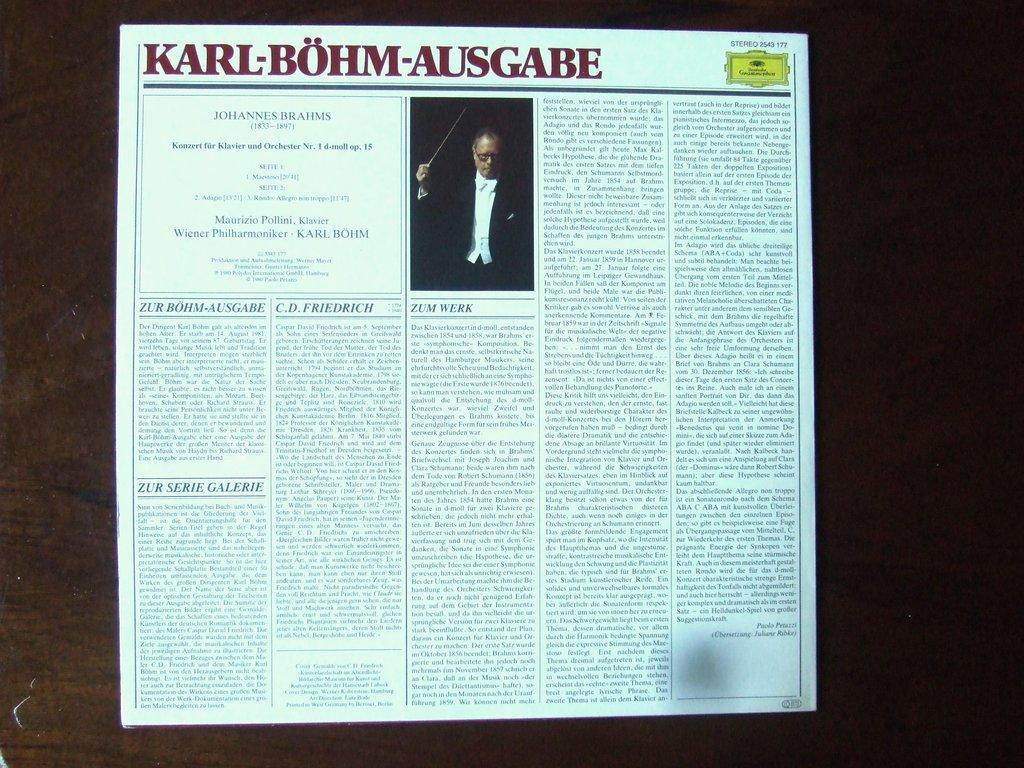<image>
Provide a brief description of the given image. Newspaper about Karl Bohm Ausgabe with a Grammophen logo on the top right. 